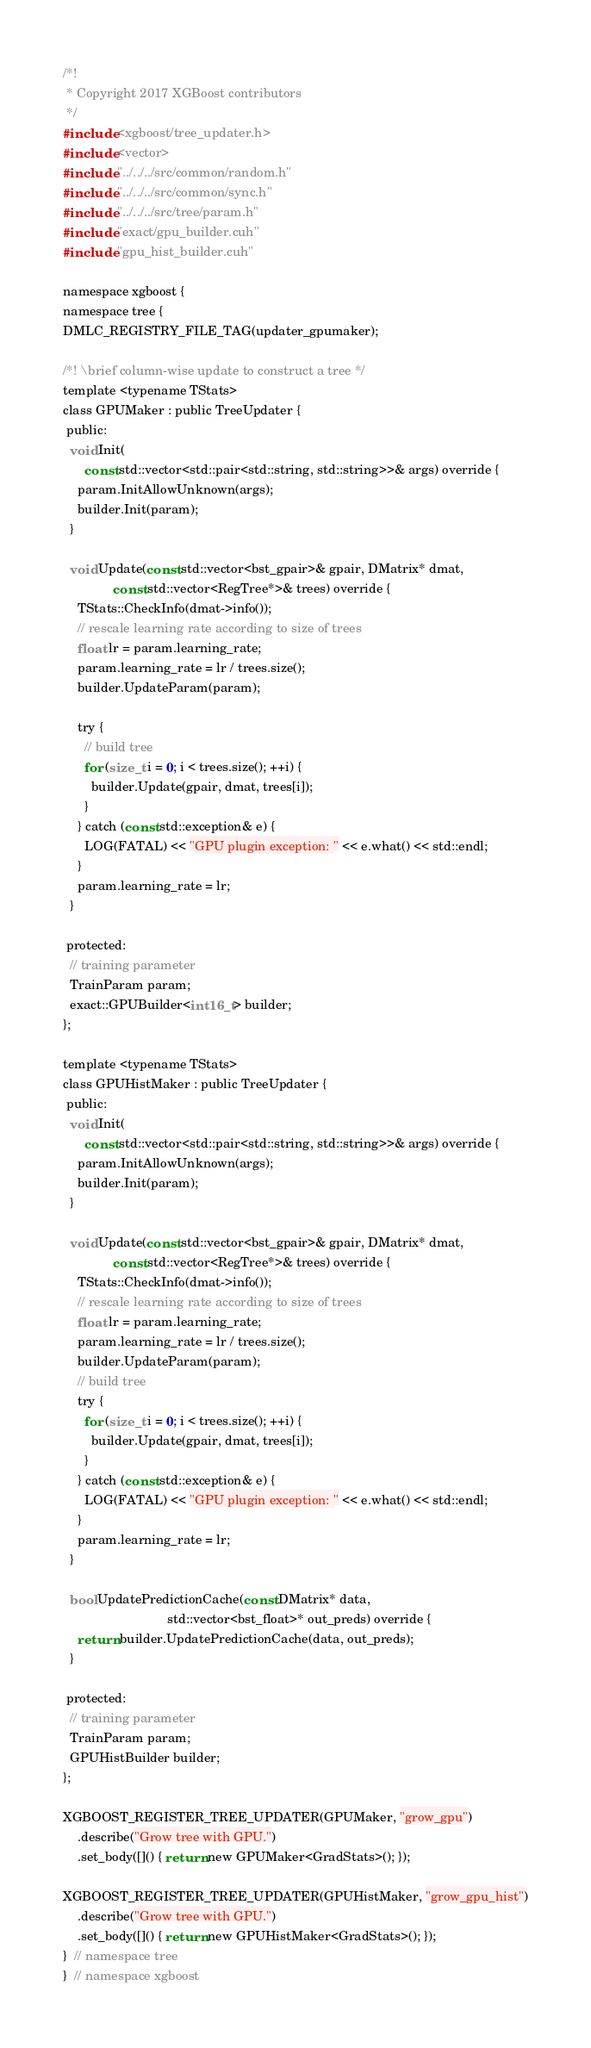Convert code to text. <code><loc_0><loc_0><loc_500><loc_500><_Cuda_>/*!
 * Copyright 2017 XGBoost contributors
 */
#include <xgboost/tree_updater.h>
#include <vector>
#include "../../../src/common/random.h"
#include "../../../src/common/sync.h"
#include "../../../src/tree/param.h"
#include "exact/gpu_builder.cuh"
#include "gpu_hist_builder.cuh"

namespace xgboost {
namespace tree {
DMLC_REGISTRY_FILE_TAG(updater_gpumaker);

/*! \brief column-wise update to construct a tree */
template <typename TStats>
class GPUMaker : public TreeUpdater {
 public:
  void Init(
      const std::vector<std::pair<std::string, std::string>>& args) override {
    param.InitAllowUnknown(args);
    builder.Init(param);
  }

  void Update(const std::vector<bst_gpair>& gpair, DMatrix* dmat,
              const std::vector<RegTree*>& trees) override {
    TStats::CheckInfo(dmat->info());
    // rescale learning rate according to size of trees
    float lr = param.learning_rate;
    param.learning_rate = lr / trees.size();
    builder.UpdateParam(param);

    try {
      // build tree
      for (size_t i = 0; i < trees.size(); ++i) {
        builder.Update(gpair, dmat, trees[i]);
      }
    } catch (const std::exception& e) {
      LOG(FATAL) << "GPU plugin exception: " << e.what() << std::endl;
    }
    param.learning_rate = lr;
  }

 protected:
  // training parameter
  TrainParam param;
  exact::GPUBuilder<int16_t> builder;
};

template <typename TStats>
class GPUHistMaker : public TreeUpdater {
 public:
  void Init(
      const std::vector<std::pair<std::string, std::string>>& args) override {
    param.InitAllowUnknown(args);
    builder.Init(param);
  }

  void Update(const std::vector<bst_gpair>& gpair, DMatrix* dmat,
              const std::vector<RegTree*>& trees) override {
    TStats::CheckInfo(dmat->info());
    // rescale learning rate according to size of trees
    float lr = param.learning_rate;
    param.learning_rate = lr / trees.size();
    builder.UpdateParam(param);
    // build tree
    try {
      for (size_t i = 0; i < trees.size(); ++i) {
        builder.Update(gpair, dmat, trees[i]);
      }
    } catch (const std::exception& e) {
      LOG(FATAL) << "GPU plugin exception: " << e.what() << std::endl;
    }
    param.learning_rate = lr;
  }

  bool UpdatePredictionCache(const DMatrix* data,
                             std::vector<bst_float>* out_preds) override {
    return builder.UpdatePredictionCache(data, out_preds);
  }

 protected:
  // training parameter
  TrainParam param;
  GPUHistBuilder builder;
};

XGBOOST_REGISTER_TREE_UPDATER(GPUMaker, "grow_gpu")
    .describe("Grow tree with GPU.")
    .set_body([]() { return new GPUMaker<GradStats>(); });

XGBOOST_REGISTER_TREE_UPDATER(GPUHistMaker, "grow_gpu_hist")
    .describe("Grow tree with GPU.")
    .set_body([]() { return new GPUHistMaker<GradStats>(); });
}  // namespace tree
}  // namespace xgboost
</code> 